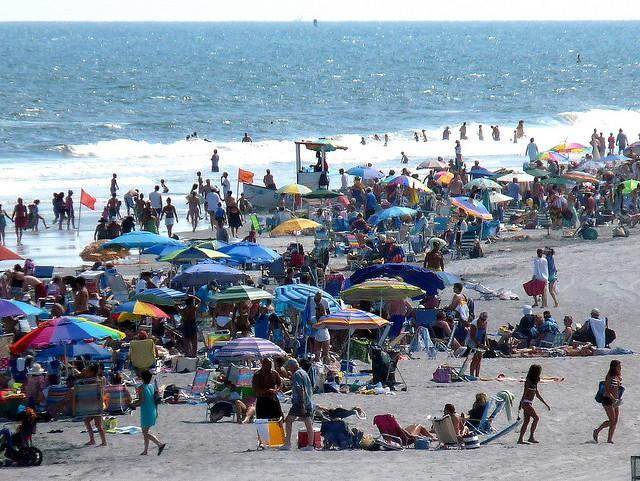What is the person in the elevated stand watching?

Choices:
A) sunset
B) swimmers
C) boats
D) sea slugs swimmers 